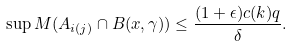Convert formula to latex. <formula><loc_0><loc_0><loc_500><loc_500>\sup M ( A _ { i ( j ) } \cap B ( x , \gamma ) ) \leq \frac { ( 1 + \epsilon ) c ( k ) q } { \delta } .</formula> 